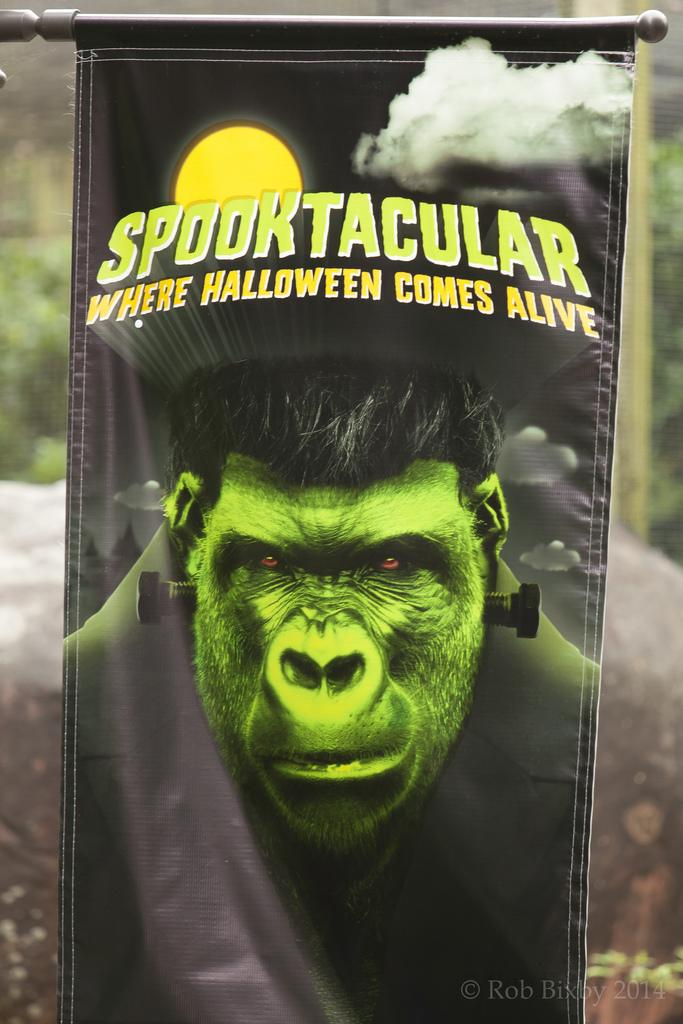What is the main subject of the poster in the image? The poster features a cartoon face of a chimpanzee. What else can be seen on the poster besides the chimpanzee? There is text on the poster. Can you describe the background of the image? The background of the image is blurry. Where is some additional text located in the image? There is some text at the bottom right of the image. What type of rhythm does the snail in the image follow? There is no snail present in the image; it features a cartoon face of a chimpanzee. What subject is being taught in the image? There is no teaching or lesson being depicted in the image; it is a poster with a cartoon face of a chimpanzee and text. 